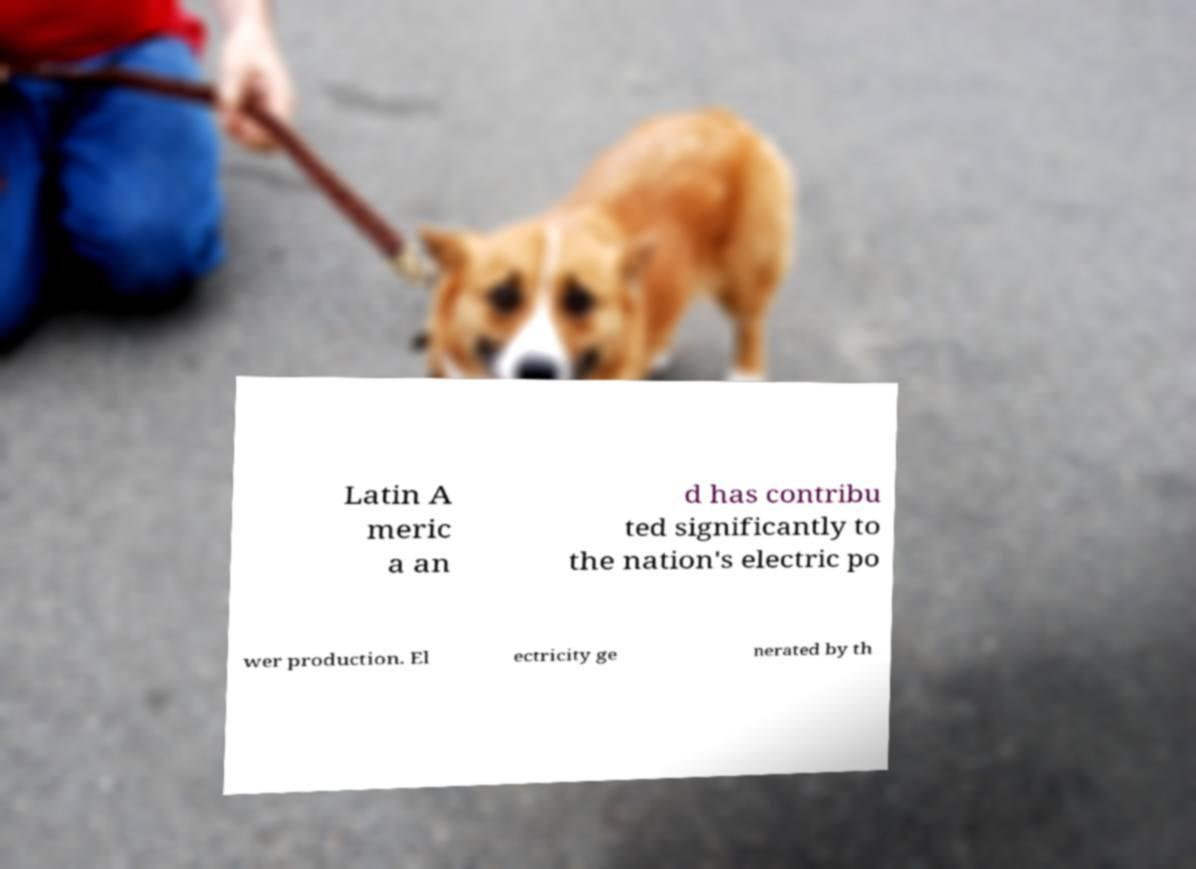Could you extract and type out the text from this image? Latin A meric a an d has contribu ted significantly to the nation's electric po wer production. El ectricity ge nerated by th 